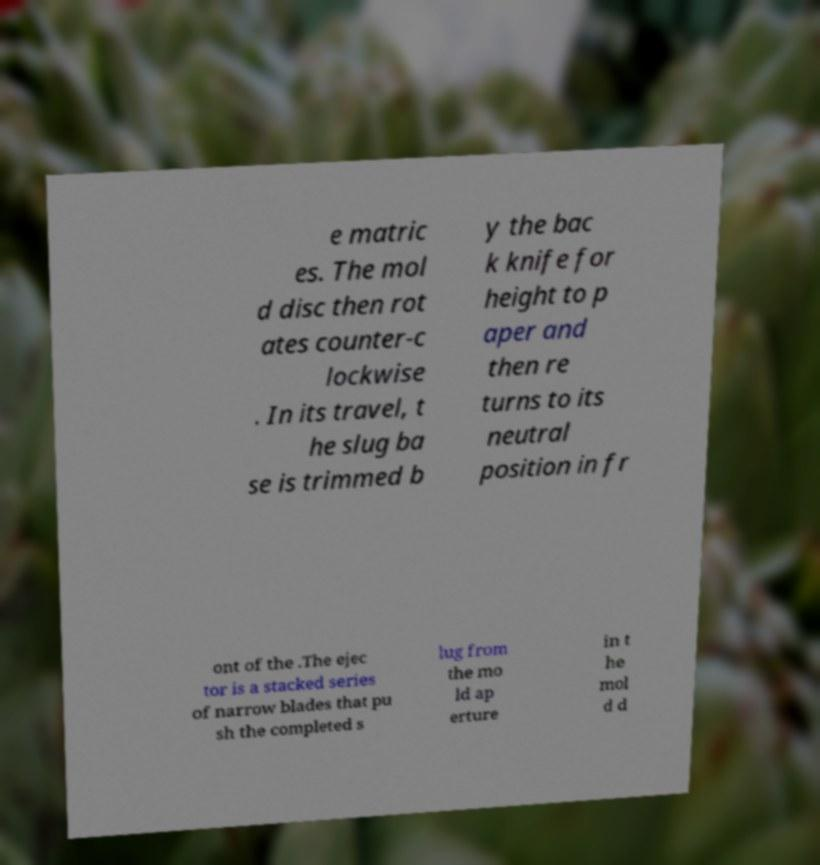What messages or text are displayed in this image? I need them in a readable, typed format. e matric es. The mol d disc then rot ates counter-c lockwise . In its travel, t he slug ba se is trimmed b y the bac k knife for height to p aper and then re turns to its neutral position in fr ont of the .The ejec tor is a stacked series of narrow blades that pu sh the completed s lug from the mo ld ap erture in t he mol d d 